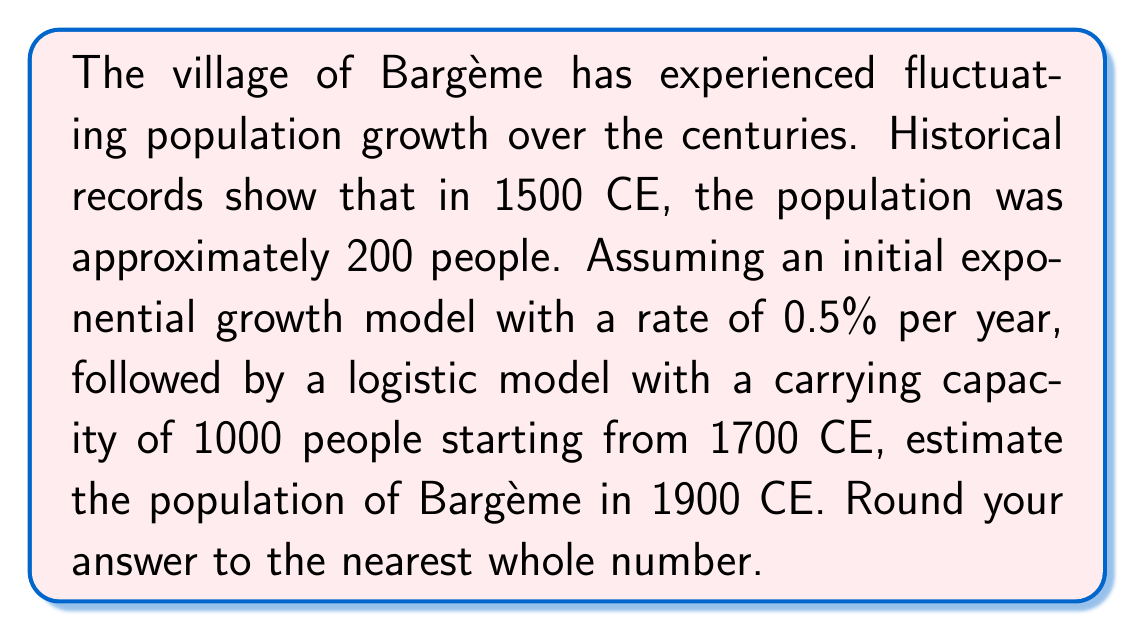Could you help me with this problem? Let's approach this problem step-by-step:

1. Exponential growth from 1500 to 1700 CE:
   We use the exponential growth formula: $P(t) = P_0 e^{rt}$
   Where $P_0 = 200$, $r = 0.005$, and $t = 200$ years
   
   $P(1700) = 200 e^{0.005 * 200} \approx 271.83$

2. Logistic growth from 1700 to 1900 CE:
   We use the logistic growth formula: $P(t) = \frac{K}{1 + (\frac{K}{P_0} - 1)e^{-rt}}$
   Where $K = 1000$ (carrying capacity), $P_0 = 271.83$ (from step 1), $r$ is the growth rate we need to determine, and $t = 200$ years

3. To find $r$ for the logistic model, we can assume it's similar to the exponential rate. Let's use $r = 0.005$.

4. Now we can calculate the population in 1900:

   $P(1900) = \frac{1000}{1 + (\frac{1000}{271.83} - 1)e^{-0.005 * 200}}$

5. Simplifying:
   $P(1900) = \frac{1000}{1 + 2.6788 * e^{-1}}$
   $P(1900) = \frac{1000}{1 + 0.9858}$
   $P(1900) = \frac{1000}{1.9858}$
   $P(1900) \approx 503.57$

6. Rounding to the nearest whole number: 504
Answer: 504 